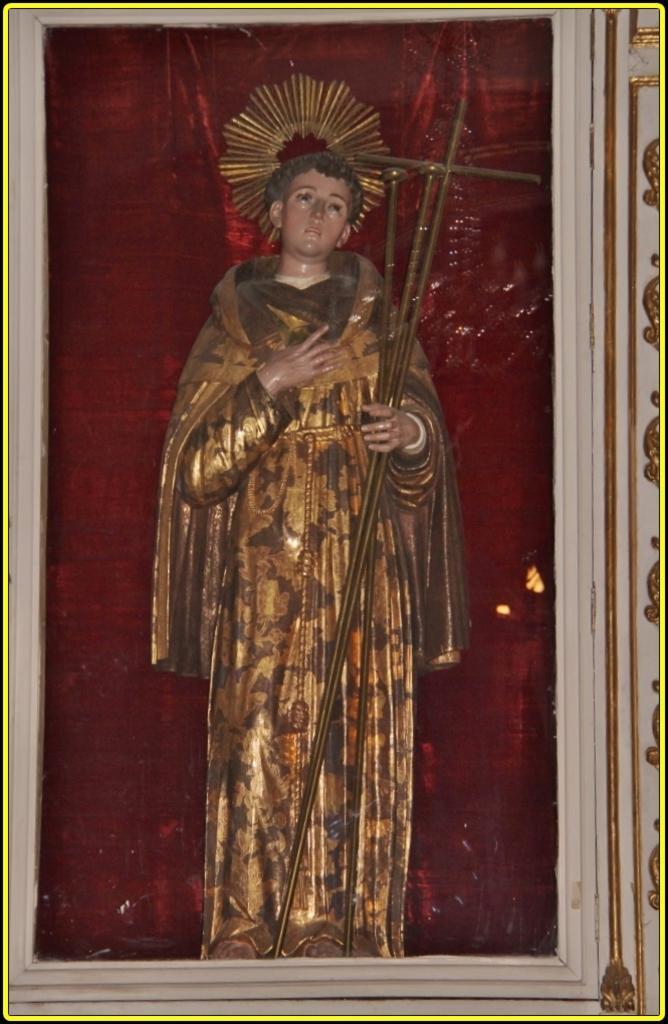Please provide a concise description of this image. This picture shows a statue in the glass box and we see red color cloth on the back. 